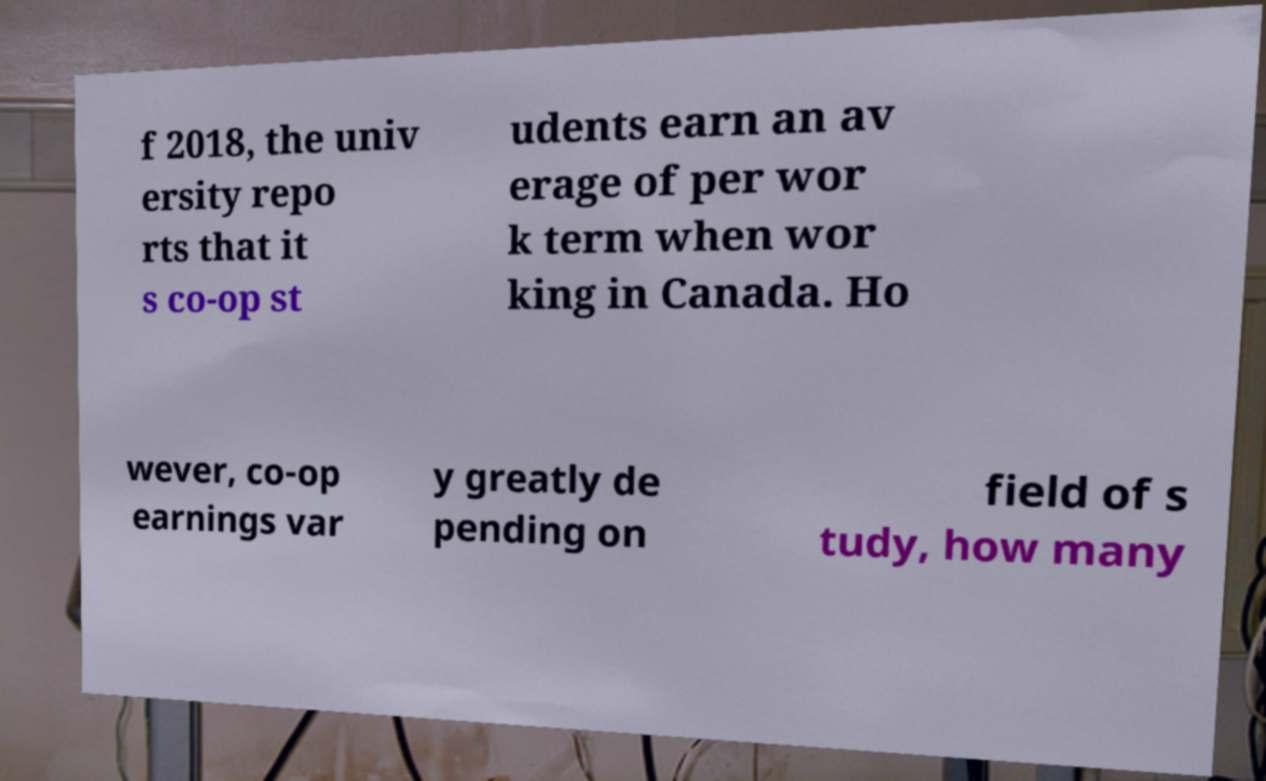For documentation purposes, I need the text within this image transcribed. Could you provide that? f 2018, the univ ersity repo rts that it s co-op st udents earn an av erage of per wor k term when wor king in Canada. Ho wever, co-op earnings var y greatly de pending on field of s tudy, how many 